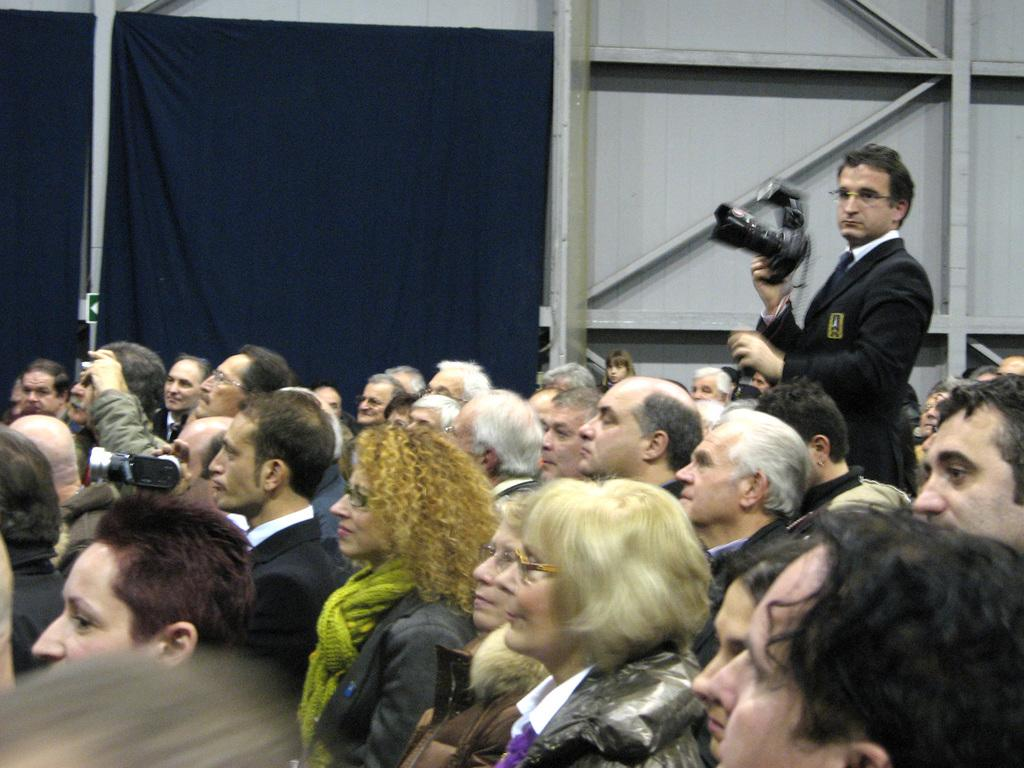Who or what can be seen in the image? There are persons in the image. What are the persons holding or using in the image? There are cameras in the image. Can you describe the background of the image? There are curtains and poles in the background of the image, along with other objects. What type of song is being sung by the person in the image? There is no person singing in the image, and no song can be heard or seen. What is the sponge used for in the image? There is no sponge present in the image. 